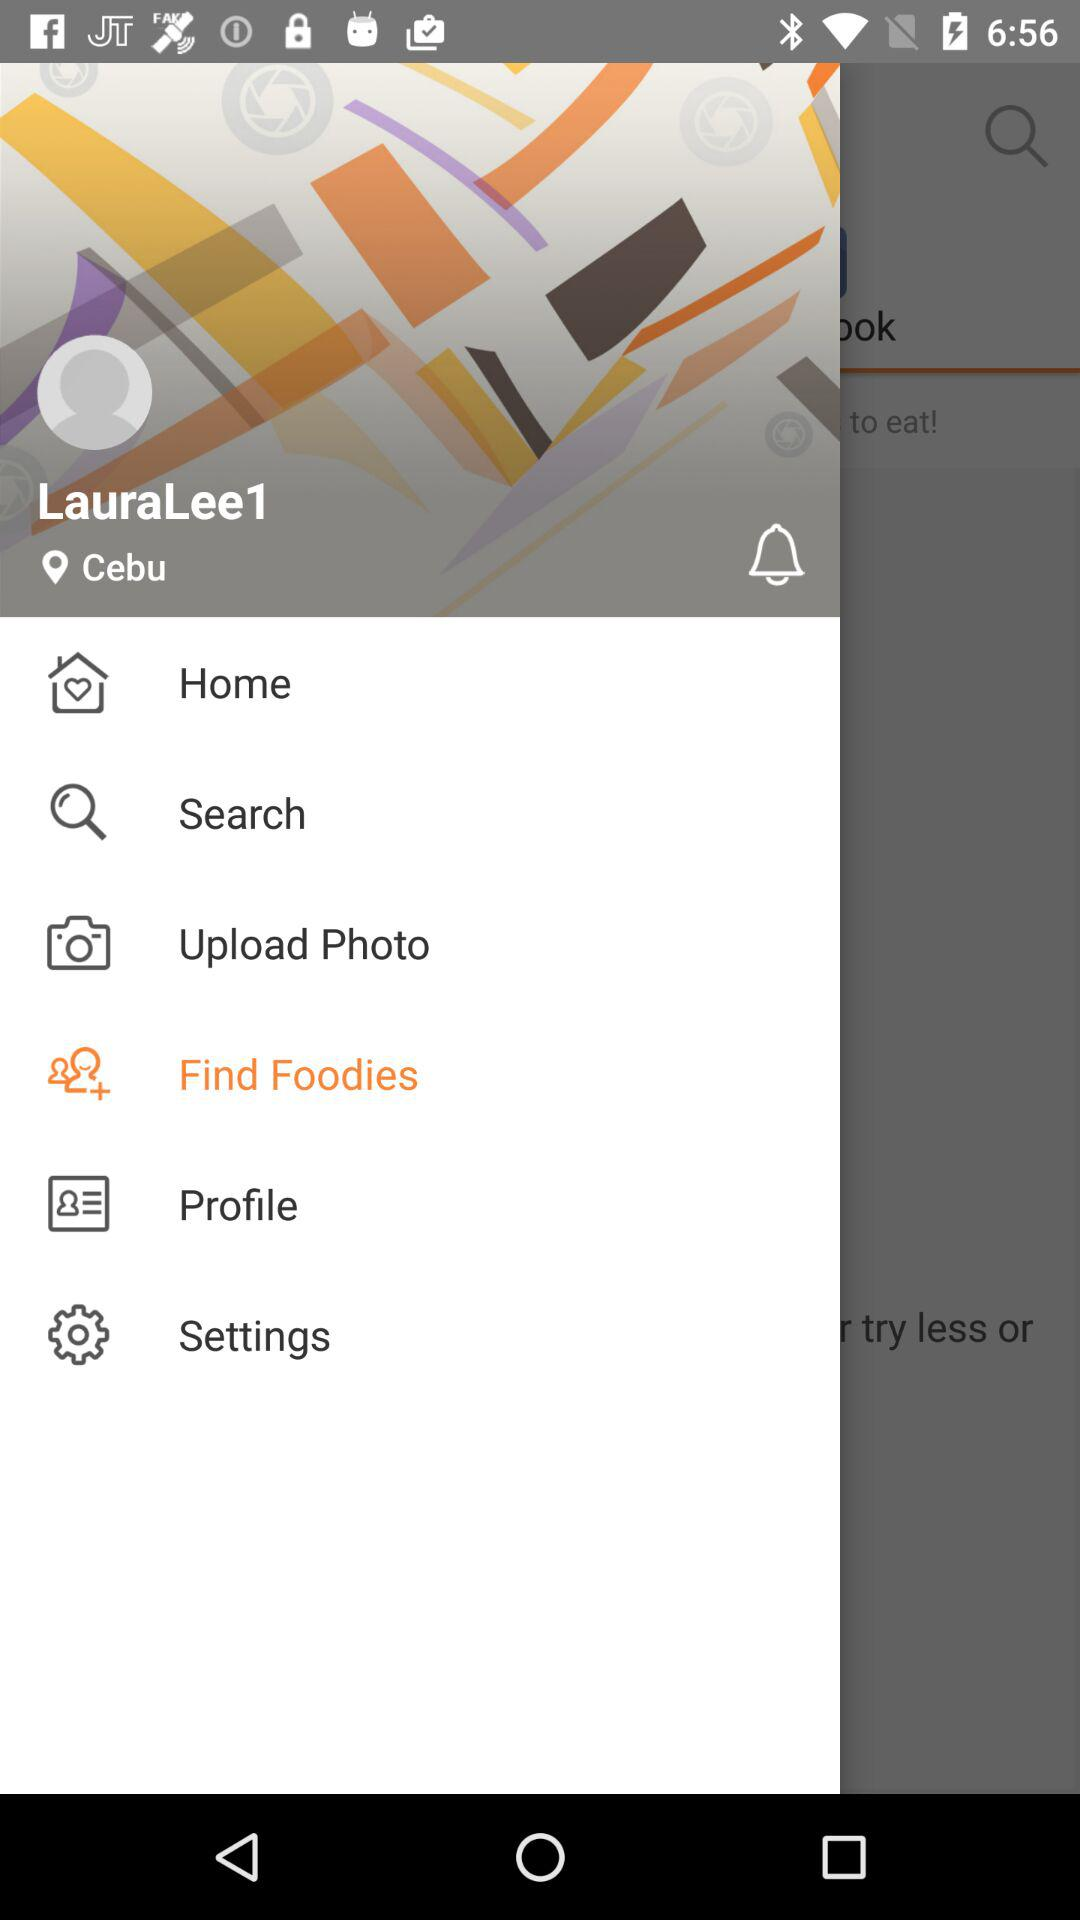What is the location of the user? The location of the user is Cebu. 